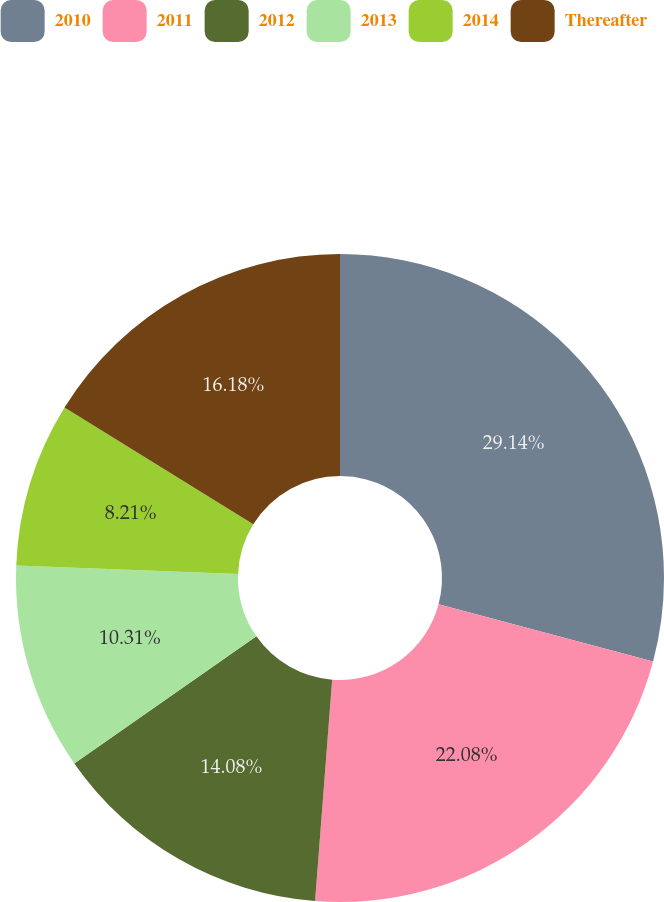Convert chart to OTSL. <chart><loc_0><loc_0><loc_500><loc_500><pie_chart><fcel>2010<fcel>2011<fcel>2012<fcel>2013<fcel>2014<fcel>Thereafter<nl><fcel>29.15%<fcel>22.08%<fcel>14.08%<fcel>10.31%<fcel>8.21%<fcel>16.18%<nl></chart> 